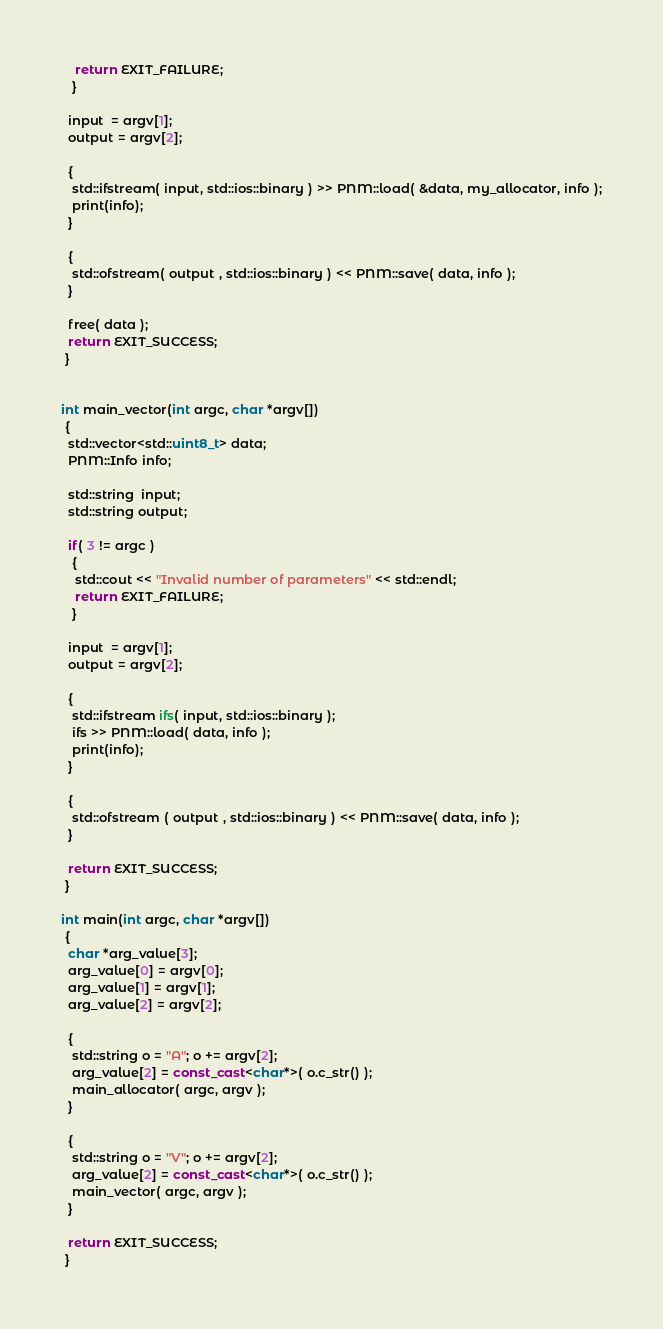<code> <loc_0><loc_0><loc_500><loc_500><_C++_>    return EXIT_FAILURE;
   }

  input  = argv[1];
  output = argv[2];

  {
   std::ifstream( input, std::ios::binary ) >> PNM::load( &data, my_allocator, info );
   print(info);
  }

  {
   std::ofstream( output , std::ios::binary ) << PNM::save( data, info );
  }

  free( data );
  return EXIT_SUCCESS;
 }


int main_vector(int argc, char *argv[])
 {
  std::vector<std::uint8_t> data;
  PNM::Info info;

  std::string  input;
  std::string output;

  if( 3 != argc )
   {
    std::cout << "Invalid number of parameters" << std::endl;
    return EXIT_FAILURE;
   }

  input  = argv[1];
  output = argv[2];

  {
   std::ifstream ifs( input, std::ios::binary );
   ifs >> PNM::load( data, info );
   print(info);
  }

  {
   std::ofstream ( output , std::ios::binary ) << PNM::save( data, info );
  }

  return EXIT_SUCCESS;
 }

int main(int argc, char *argv[])
 {
  char *arg_value[3];
  arg_value[0] = argv[0];
  arg_value[1] = argv[1];
  arg_value[2] = argv[2];

  {
   std::string o = "A"; o += argv[2];
   arg_value[2] = const_cast<char*>( o.c_str() );
   main_allocator( argc, argv );
  }

  {
   std::string o = "V"; o += argv[2];
   arg_value[2] = const_cast<char*>( o.c_str() );
   main_vector( argc, argv );
  }

  return EXIT_SUCCESS;
 }
</code> 